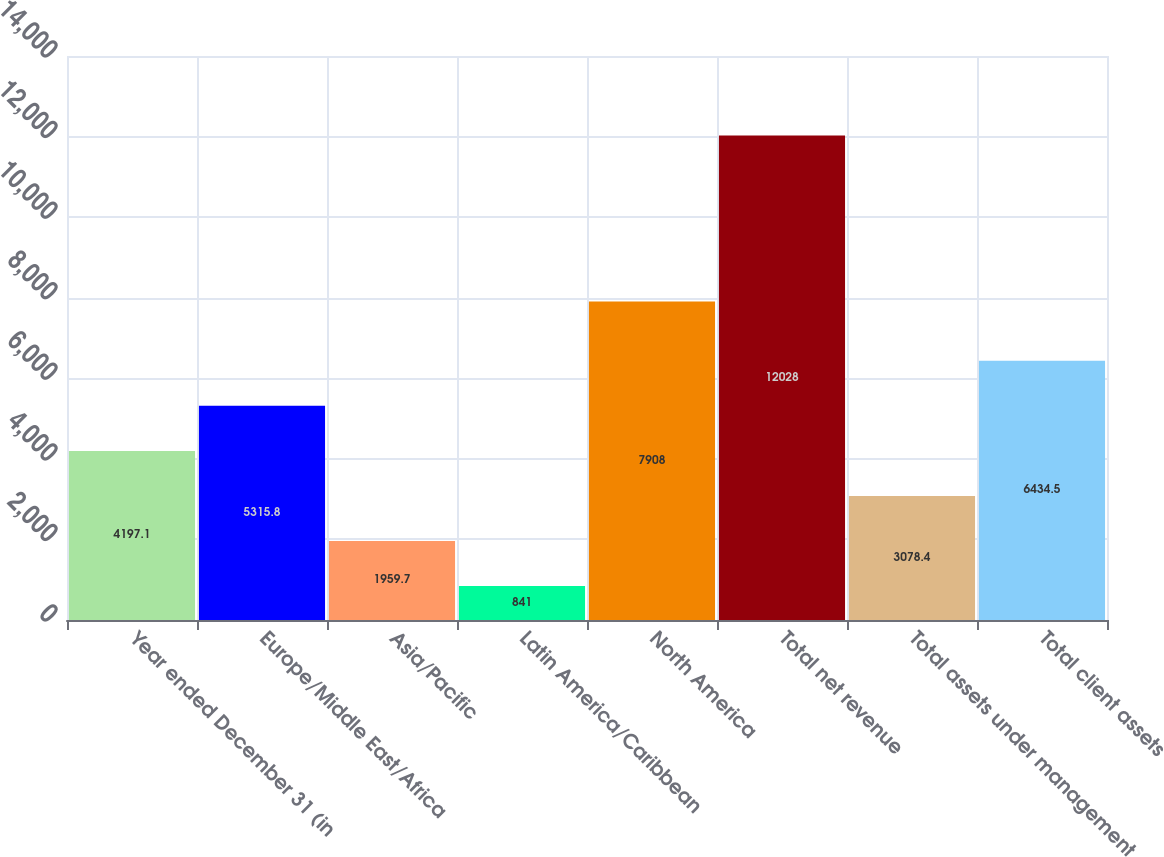<chart> <loc_0><loc_0><loc_500><loc_500><bar_chart><fcel>Year ended December 31 (in<fcel>Europe/Middle East/Africa<fcel>Asia/Pacific<fcel>Latin America/Caribbean<fcel>North America<fcel>Total net revenue<fcel>Total assets under management<fcel>Total client assets<nl><fcel>4197.1<fcel>5315.8<fcel>1959.7<fcel>841<fcel>7908<fcel>12028<fcel>3078.4<fcel>6434.5<nl></chart> 